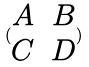<formula> <loc_0><loc_0><loc_500><loc_500>( \begin{matrix} A & B \\ C & D \end{matrix} )</formula> 